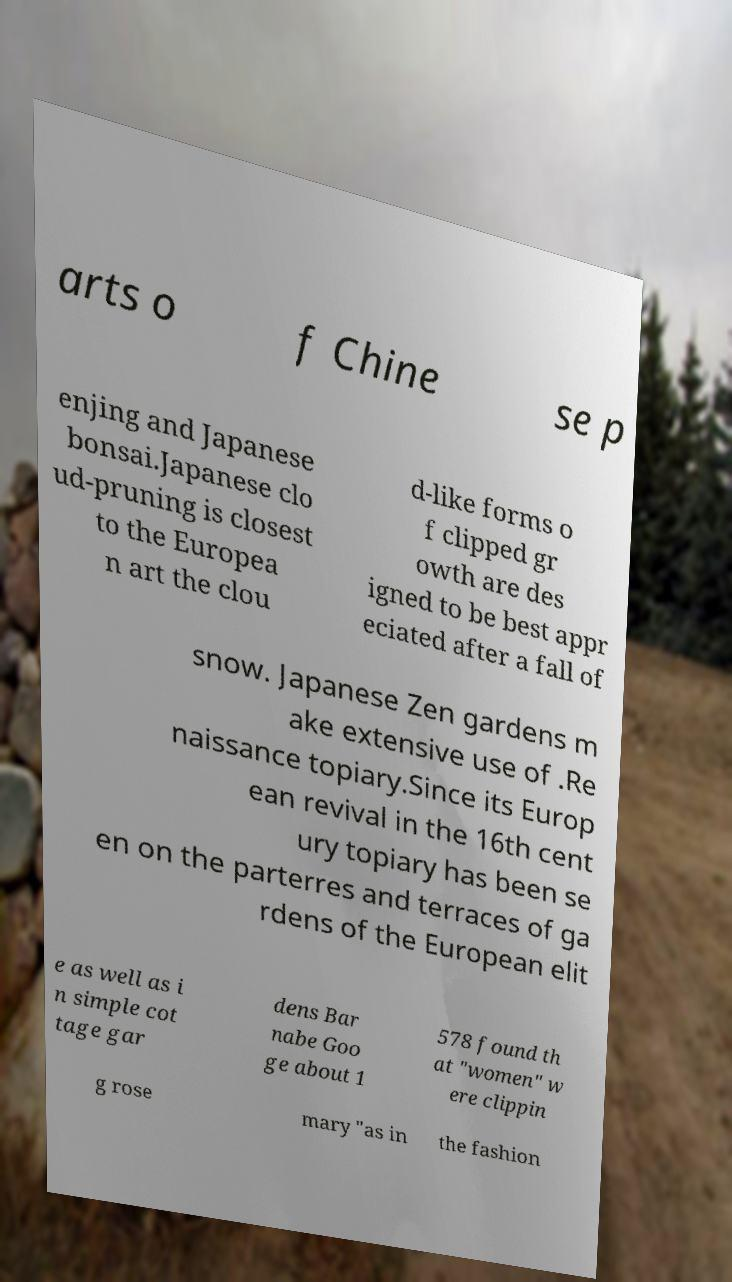What messages or text are displayed in this image? I need them in a readable, typed format. arts o f Chine se p enjing and Japanese bonsai.Japanese clo ud-pruning is closest to the Europea n art the clou d-like forms o f clipped gr owth are des igned to be best appr eciated after a fall of snow. Japanese Zen gardens m ake extensive use of .Re naissance topiary.Since its Europ ean revival in the 16th cent ury topiary has been se en on the parterres and terraces of ga rdens of the European elit e as well as i n simple cot tage gar dens Bar nabe Goo ge about 1 578 found th at "women" w ere clippin g rose mary "as in the fashion 